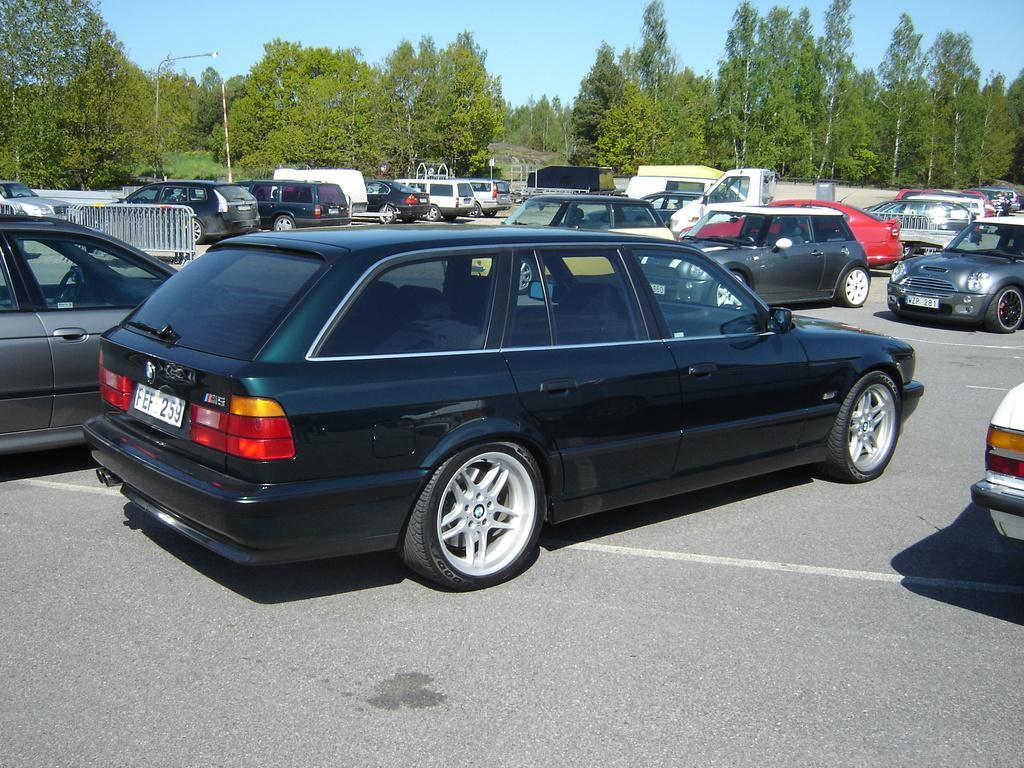Can you describe this image briefly? In this image we can see cars on the road. In the background there are trees and we can see poles. There is sky. 